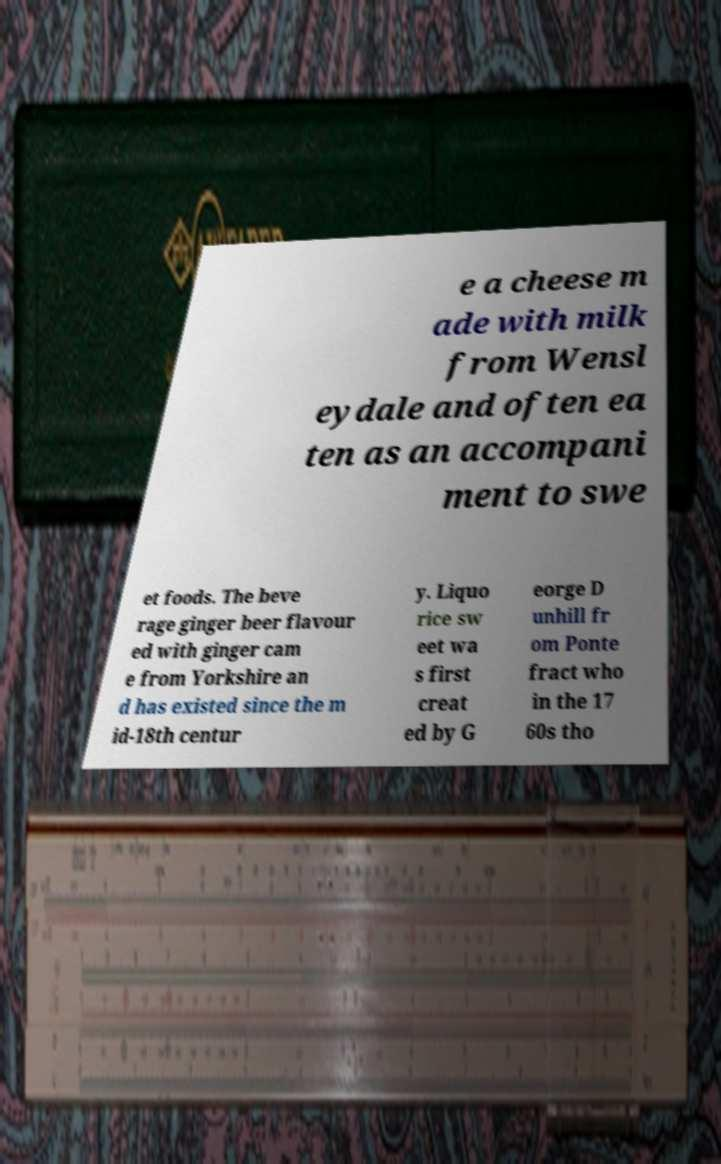What messages or text are displayed in this image? I need them in a readable, typed format. e a cheese m ade with milk from Wensl eydale and often ea ten as an accompani ment to swe et foods. The beve rage ginger beer flavour ed with ginger cam e from Yorkshire an d has existed since the m id-18th centur y. Liquo rice sw eet wa s first creat ed by G eorge D unhill fr om Ponte fract who in the 17 60s tho 